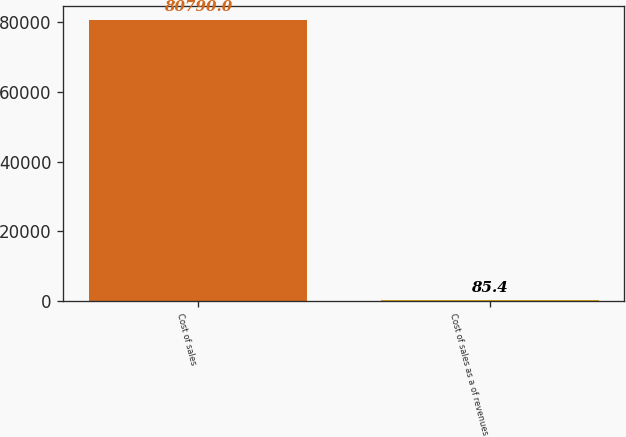<chart> <loc_0><loc_0><loc_500><loc_500><bar_chart><fcel>Cost of sales<fcel>Cost of sales as a of revenues<nl><fcel>80790<fcel>85.4<nl></chart> 